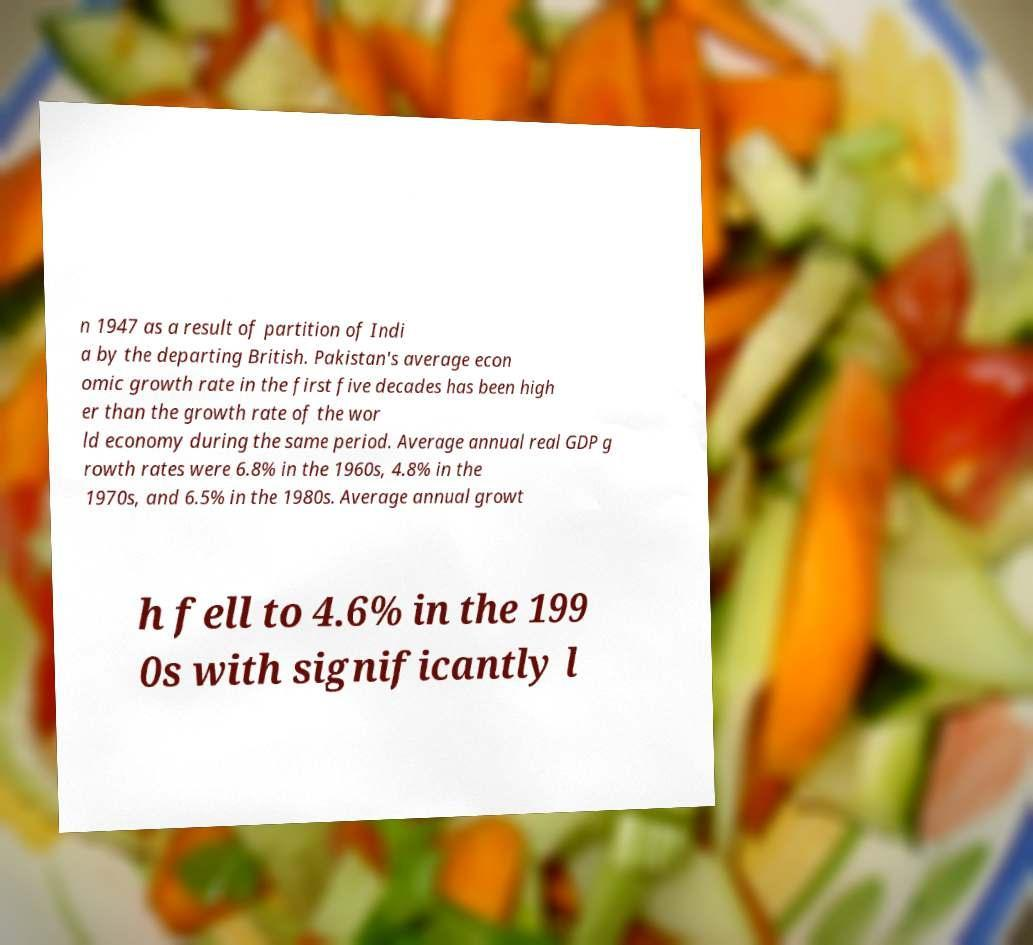I need the written content from this picture converted into text. Can you do that? n 1947 as a result of partition of Indi a by the departing British. Pakistan's average econ omic growth rate in the first five decades has been high er than the growth rate of the wor ld economy during the same period. Average annual real GDP g rowth rates were 6.8% in the 1960s, 4.8% in the 1970s, and 6.5% in the 1980s. Average annual growt h fell to 4.6% in the 199 0s with significantly l 